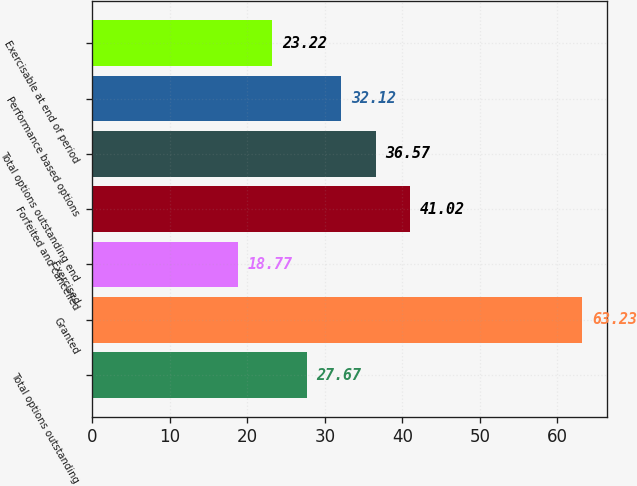Convert chart to OTSL. <chart><loc_0><loc_0><loc_500><loc_500><bar_chart><fcel>Total options outstanding<fcel>Granted<fcel>Exercised<fcel>Forfeited and cancelled<fcel>Total options outstanding end<fcel>Performance based options<fcel>Exercisable at end of period<nl><fcel>27.67<fcel>63.23<fcel>18.77<fcel>41.02<fcel>36.57<fcel>32.12<fcel>23.22<nl></chart> 